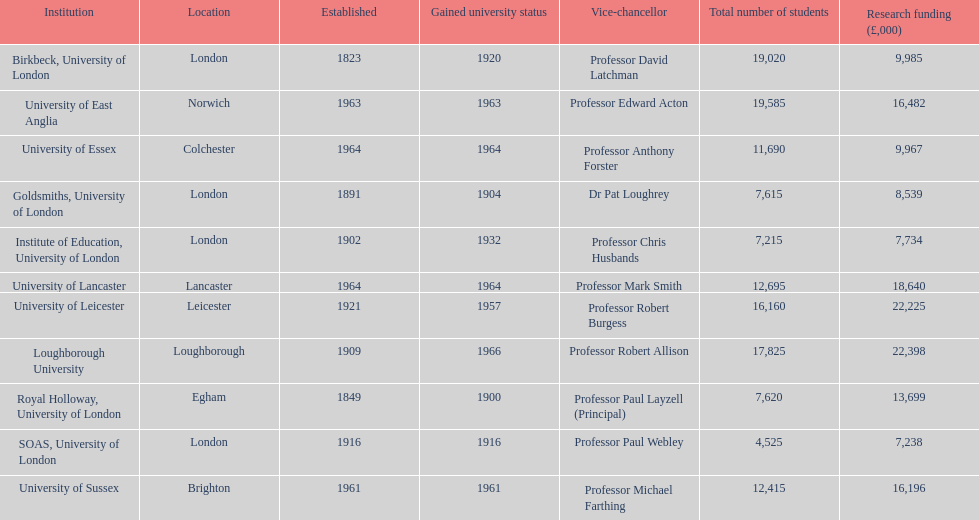How many of the institutions are located in london? 4. 